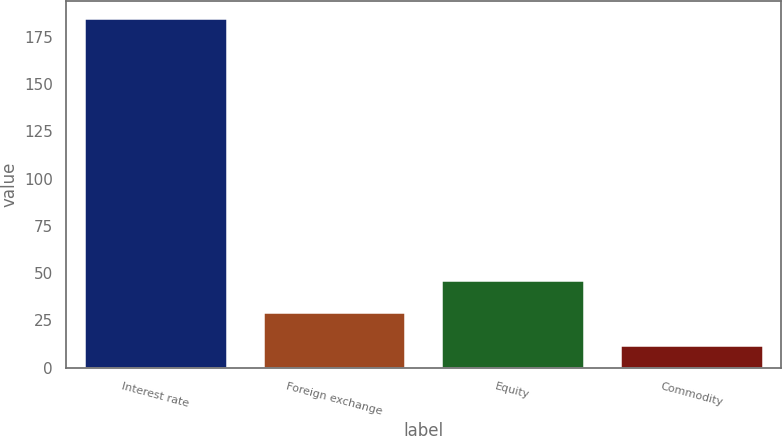<chart> <loc_0><loc_0><loc_500><loc_500><bar_chart><fcel>Interest rate<fcel>Foreign exchange<fcel>Equity<fcel>Commodity<nl><fcel>185<fcel>29.3<fcel>46.6<fcel>12<nl></chart> 